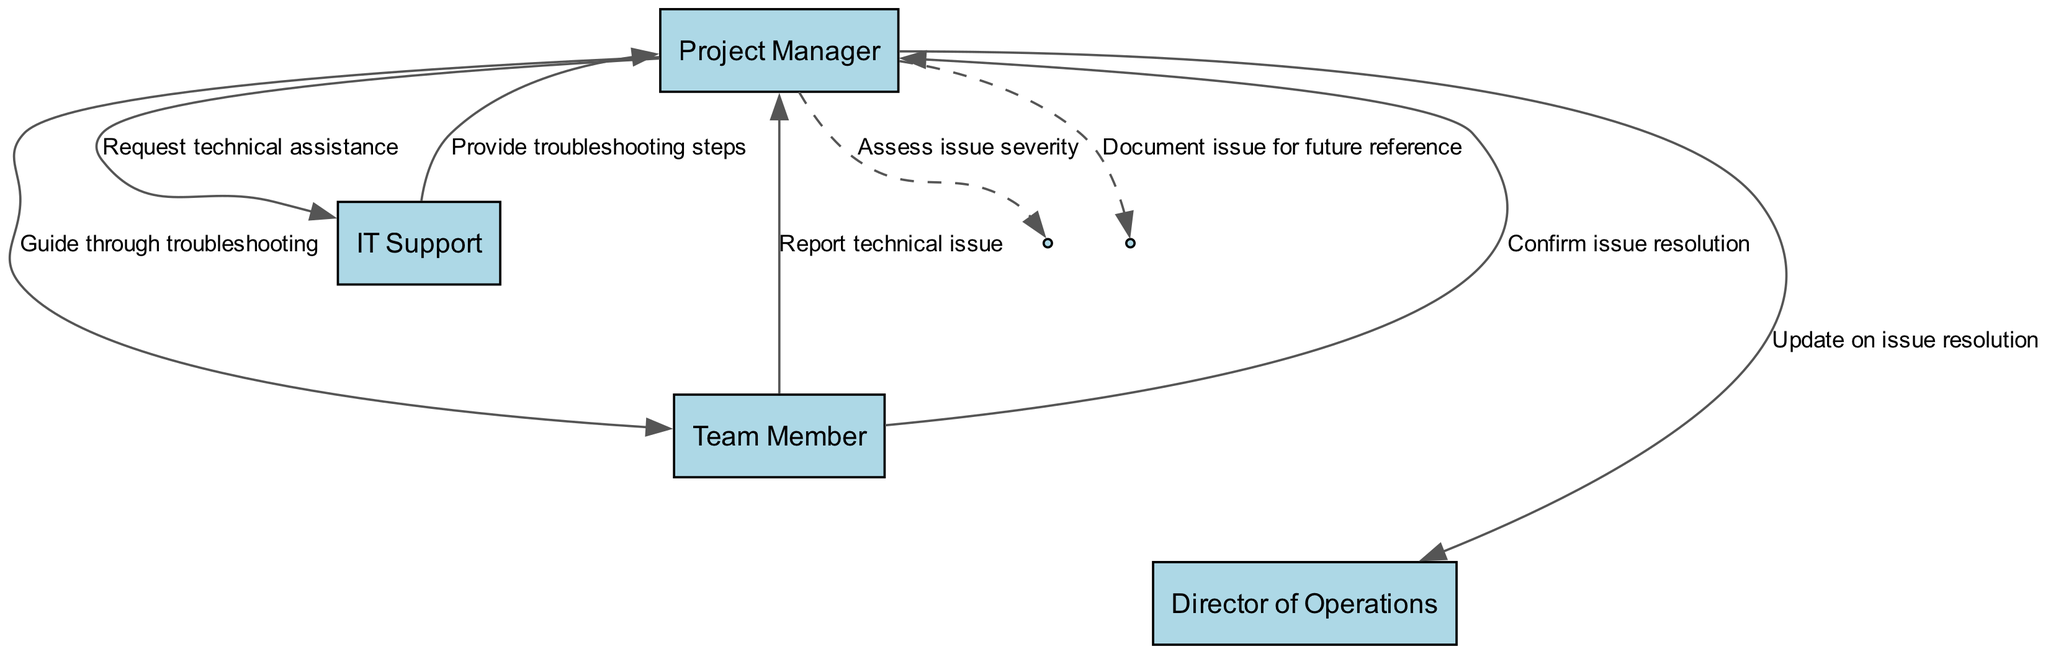What is the first message received in the sequence? The first message is sent from the Team Member to the Project Manager, which states "Report technical issue."
Answer: Report technical issue How many actors are involved in the diagram? There are four actors represented in the diagram: Project Manager, IT Support, Team Member, and Director of Operations.
Answer: 4 Who is responsible for assessing the issue severity? The Project Manager is responsible for assessing the issue severity, as indicated in the sequence.
Answer: Project Manager What message does the IT Support send to the Project Manager? IT Support sends "Provide troubleshooting steps" as the message to the Project Manager.
Answer: Provide troubleshooting steps How many messages are exchanged between the Project Manager and Team Member? The Project Manager and Team Member exchange two messages: one for guiding through troubleshooting and another confirming issue resolution.
Answer: 2 What happens after the Team Member confirms issue resolution? After the Team Member confirms issue resolution, the Project Manager updates the Director of Operations on the issue resolution.
Answer: Update on issue resolution Which actor sends the final message in the sequence? The final message in the sequence is sent by the Project Manager to document the issue for future reference.
Answer: Document issue for future reference What type of diagram is depicted here? This diagram is a Sequence Diagram, which illustrates the interactions and order of messages between the actors.
Answer: Sequence Diagram What is the purpose of documenting the issue at the end of the process? Documenting the issue serves for future reference to help in handling similar issues that may arise later.
Answer: Future reference 